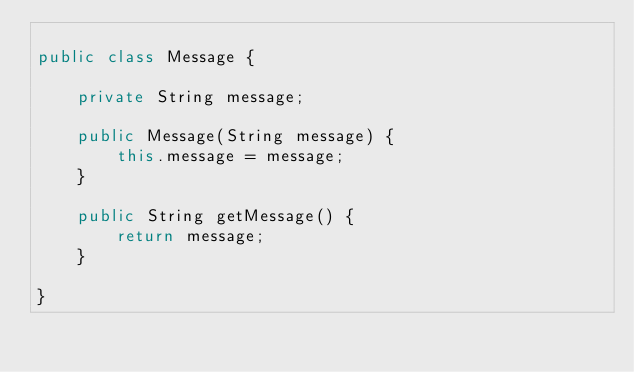Convert code to text. <code><loc_0><loc_0><loc_500><loc_500><_Java_>
public class Message {

    private String message;

    public Message(String message) {
        this.message = message;
    }

    public String getMessage() {
        return message;
    }

}</code> 